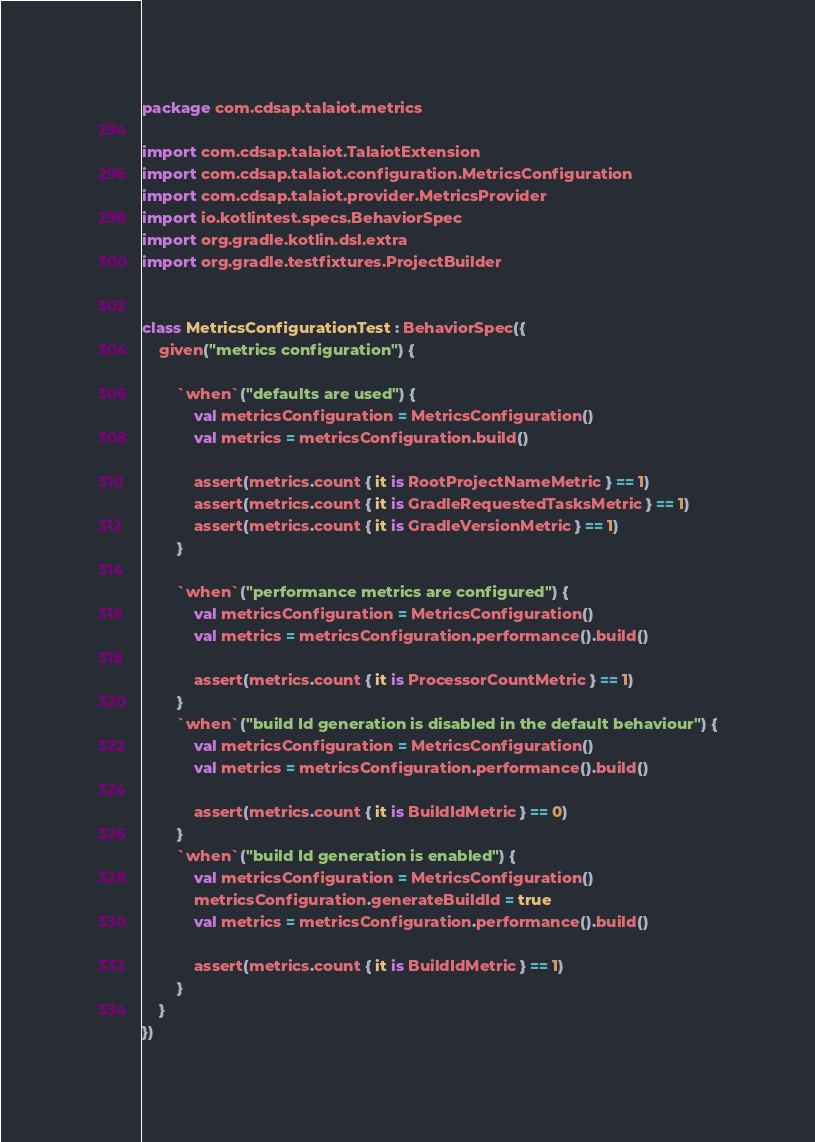Convert code to text. <code><loc_0><loc_0><loc_500><loc_500><_Kotlin_>package com.cdsap.talaiot.metrics

import com.cdsap.talaiot.TalaiotExtension
import com.cdsap.talaiot.configuration.MetricsConfiguration
import com.cdsap.talaiot.provider.MetricsProvider
import io.kotlintest.specs.BehaviorSpec
import org.gradle.kotlin.dsl.extra
import org.gradle.testfixtures.ProjectBuilder


class MetricsConfigurationTest : BehaviorSpec({
    given("metrics configuration") {

        `when`("defaults are used") {
            val metricsConfiguration = MetricsConfiguration()
            val metrics = metricsConfiguration.build()

            assert(metrics.count { it is RootProjectNameMetric } == 1)
            assert(metrics.count { it is GradleRequestedTasksMetric } == 1)
            assert(metrics.count { it is GradleVersionMetric } == 1)
        }

        `when`("performance metrics are configured") {
            val metricsConfiguration = MetricsConfiguration()
            val metrics = metricsConfiguration.performance().build()

            assert(metrics.count { it is ProcessorCountMetric } == 1)
        }
        `when`("build Id generation is disabled in the default behaviour") {
            val metricsConfiguration = MetricsConfiguration()
            val metrics = metricsConfiguration.performance().build()

            assert(metrics.count { it is BuildIdMetric } == 0)
        }
        `when`("build Id generation is enabled") {
            val metricsConfiguration = MetricsConfiguration()
            metricsConfiguration.generateBuildId = true
            val metrics = metricsConfiguration.performance().build()

            assert(metrics.count { it is BuildIdMetric } == 1)
        }
    }
})
</code> 